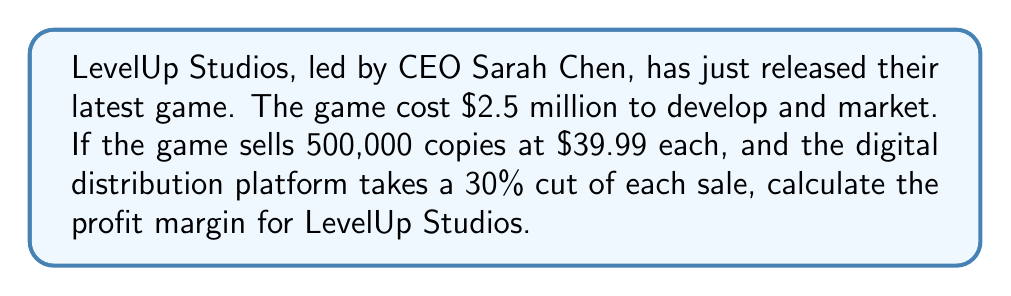Could you help me with this problem? Let's break this down step-by-step:

1. Calculate the total revenue:
   $$ \text{Total Revenue} = \text{Number of copies} \times \text{Price per copy} $$
   $$ \text{Total Revenue} = 500,000 \times \$39.99 = \$19,995,000 $$

2. Calculate the distribution platform's cut:
   $$ \text{Platform Cut} = 30\% \times \text{Total Revenue} $$
   $$ \text{Platform Cut} = 0.30 \times \$19,995,000 = \$5,998,500 $$

3. Calculate the studio's revenue after the platform cut:
   $$ \text{Studio Revenue} = \text{Total Revenue} - \text{Platform Cut} $$
   $$ \text{Studio Revenue} = \$19,995,000 - \$5,998,500 = \$13,996,500 $$

4. Calculate the profit:
   $$ \text{Profit} = \text{Studio Revenue} - \text{Development Cost} $$
   $$ \text{Profit} = \$13,996,500 - \$2,500,000 = \$11,496,500 $$

5. Calculate the profit margin:
   $$ \text{Profit Margin} = \frac{\text{Profit}}{\text{Total Revenue}} \times 100\% $$
   $$ \text{Profit Margin} = \frac{\$11,496,500}{\$19,995,000} \times 100\% \approx 57.50\% $$
Answer: 57.50% 